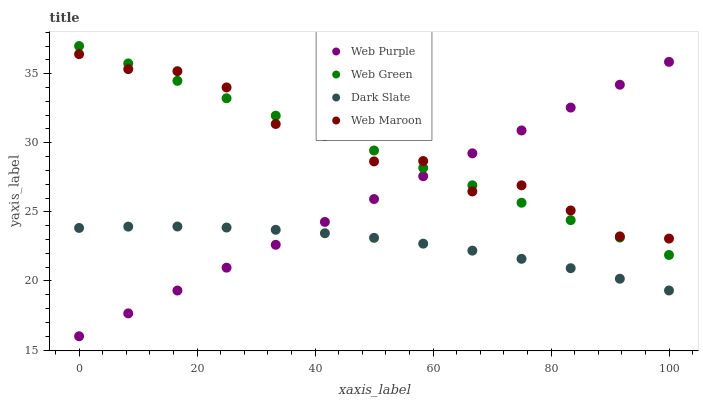Does Dark Slate have the minimum area under the curve?
Answer yes or no. Yes. Does Web Maroon have the maximum area under the curve?
Answer yes or no. Yes. Does Web Purple have the minimum area under the curve?
Answer yes or no. No. Does Web Purple have the maximum area under the curve?
Answer yes or no. No. Is Web Purple the smoothest?
Answer yes or no. Yes. Is Web Maroon the roughest?
Answer yes or no. Yes. Is Web Maroon the smoothest?
Answer yes or no. No. Is Web Purple the roughest?
Answer yes or no. No. Does Web Purple have the lowest value?
Answer yes or no. Yes. Does Web Maroon have the lowest value?
Answer yes or no. No. Does Web Green have the highest value?
Answer yes or no. Yes. Does Web Purple have the highest value?
Answer yes or no. No. Is Dark Slate less than Web Green?
Answer yes or no. Yes. Is Web Maroon greater than Dark Slate?
Answer yes or no. Yes. Does Dark Slate intersect Web Purple?
Answer yes or no. Yes. Is Dark Slate less than Web Purple?
Answer yes or no. No. Is Dark Slate greater than Web Purple?
Answer yes or no. No. Does Dark Slate intersect Web Green?
Answer yes or no. No. 